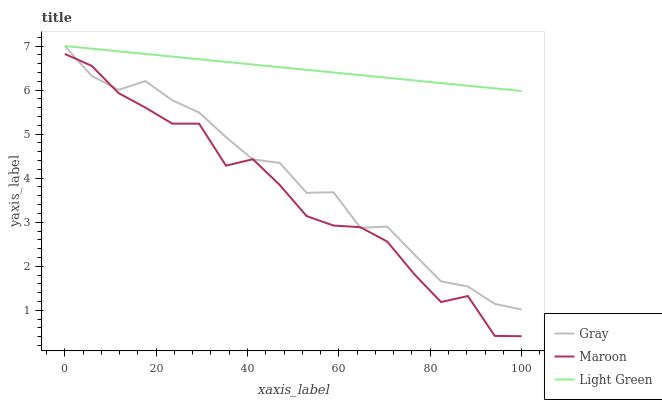Does Maroon have the minimum area under the curve?
Answer yes or no. Yes. Does Light Green have the maximum area under the curve?
Answer yes or no. Yes. Does Light Green have the minimum area under the curve?
Answer yes or no. No. Does Maroon have the maximum area under the curve?
Answer yes or no. No. Is Light Green the smoothest?
Answer yes or no. Yes. Is Maroon the roughest?
Answer yes or no. Yes. Is Maroon the smoothest?
Answer yes or no. No. Is Light Green the roughest?
Answer yes or no. No. Does Maroon have the lowest value?
Answer yes or no. Yes. Does Light Green have the lowest value?
Answer yes or no. No. Does Light Green have the highest value?
Answer yes or no. Yes. Does Maroon have the highest value?
Answer yes or no. No. Is Maroon less than Light Green?
Answer yes or no. Yes. Is Light Green greater than Maroon?
Answer yes or no. Yes. Does Gray intersect Maroon?
Answer yes or no. Yes. Is Gray less than Maroon?
Answer yes or no. No. Is Gray greater than Maroon?
Answer yes or no. No. Does Maroon intersect Light Green?
Answer yes or no. No. 